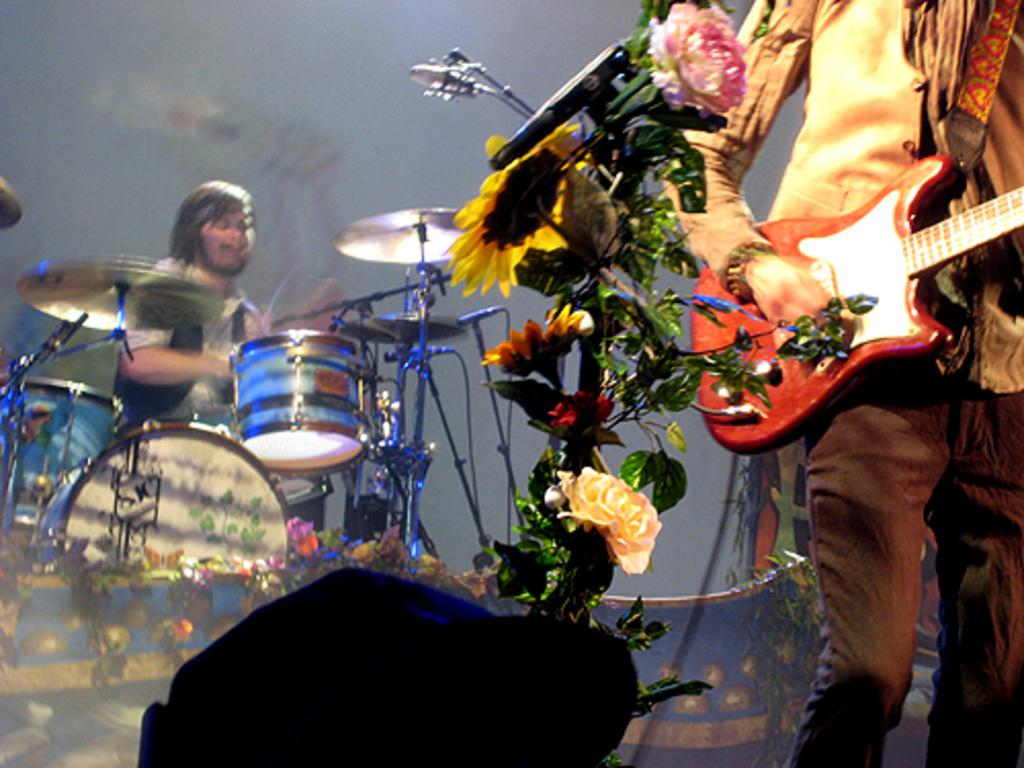How many people are in the image? There are two people in the image. What is one person holding in the image? One person is holding a guitar. What musical instrument can be seen in the image besides the guitar? There are drums in the image. What type of vegetation is present in the image? There is a plant in the image. How many pizzas are being served at the party in the image? There is no party or pizzas present in the image. What emotion is the person holding the guitar feeling in the image? The image does not provide information about the emotions of the people in the image, so we cannot determine if the person holding the guitar is feeling regret or any other emotion. 